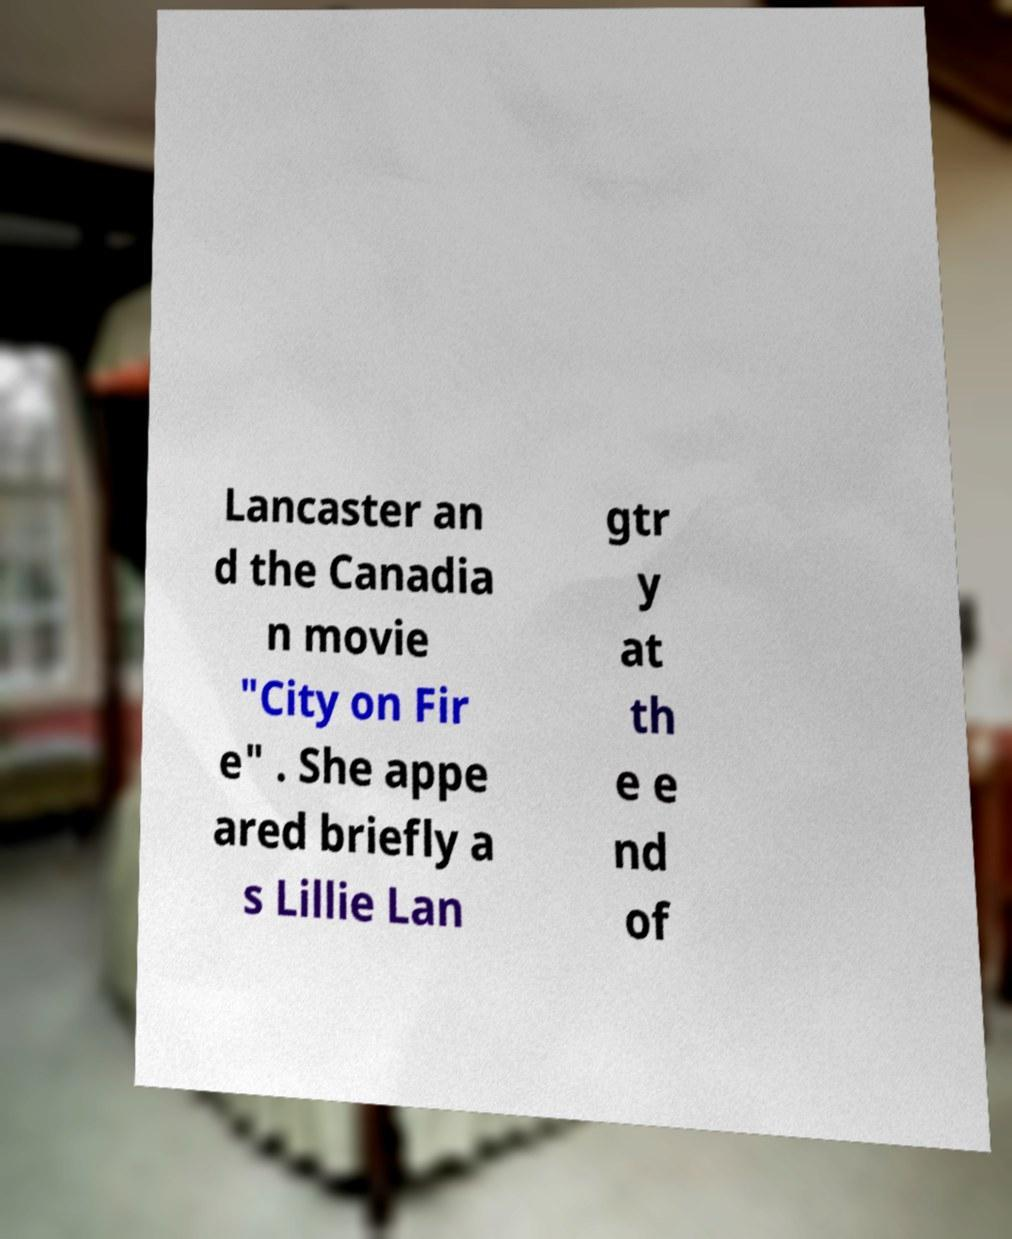Please read and relay the text visible in this image. What does it say? Lancaster an d the Canadia n movie "City on Fir e" . She appe ared briefly a s Lillie Lan gtr y at th e e nd of 